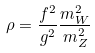Convert formula to latex. <formula><loc_0><loc_0><loc_500><loc_500>\rho = \frac { f ^ { 2 } } { g ^ { 2 } } \frac { m _ { W } ^ { 2 } } { m _ { Z } ^ { 2 } }</formula> 